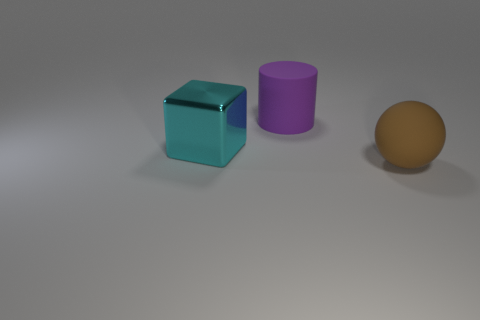Add 1 yellow matte cubes. How many objects exist? 4 Subtract all cylinders. How many objects are left? 2 Subtract all green spheres. Subtract all matte cylinders. How many objects are left? 2 Add 3 cyan metallic things. How many cyan metallic things are left? 4 Add 3 big brown balls. How many big brown balls exist? 4 Subtract 1 cyan blocks. How many objects are left? 2 